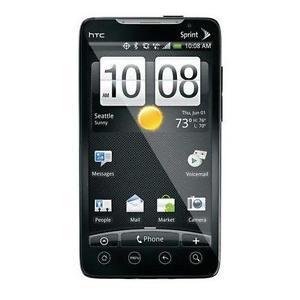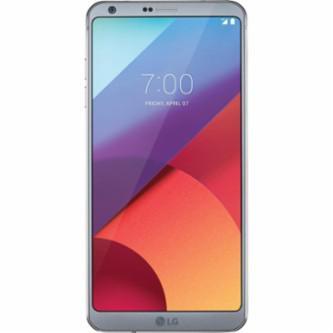The first image is the image on the left, the second image is the image on the right. Assess this claim about the two images: "All phones are shown upright, and none of them have physical keyboards.". Correct or not? Answer yes or no. Yes. The first image is the image on the left, the second image is the image on the right. Examine the images to the left and right. Is the description "All devices are rectangular and displayed vertically, and at least one device has geometric shapes of different colors filling its screen." accurate? Answer yes or no. Yes. 